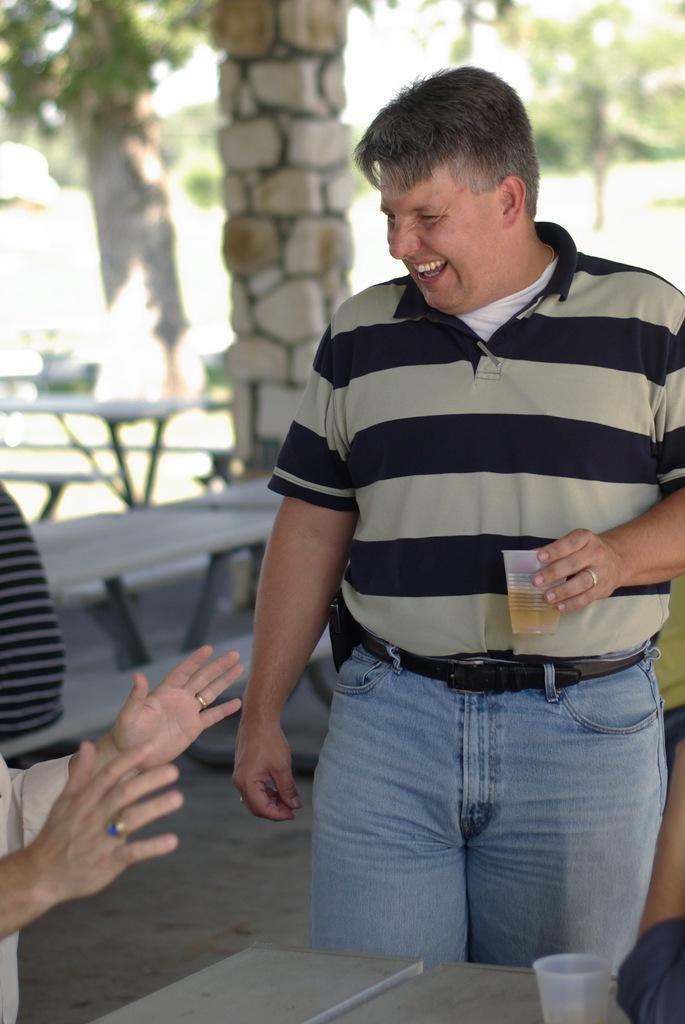In one or two sentences, can you explain what this image depicts? In this image we can see a man is standing and smiling. He is wearing brown-black color t-shirt with jeans and holding glass in his hand. At the bottom of the image table is there. On table, glass is present. Left side of the image one more person is there. Background of the image table, chair, pillars and trees are there. 